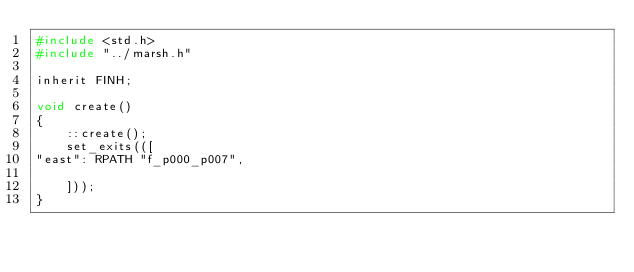Convert code to text. <code><loc_0><loc_0><loc_500><loc_500><_C_>#include <std.h>
#include "../marsh.h"

inherit FINH;

void create()
{
    ::create();
    set_exits(([
"east": RPATH "f_p000_p007",

    ]));
}

</code> 